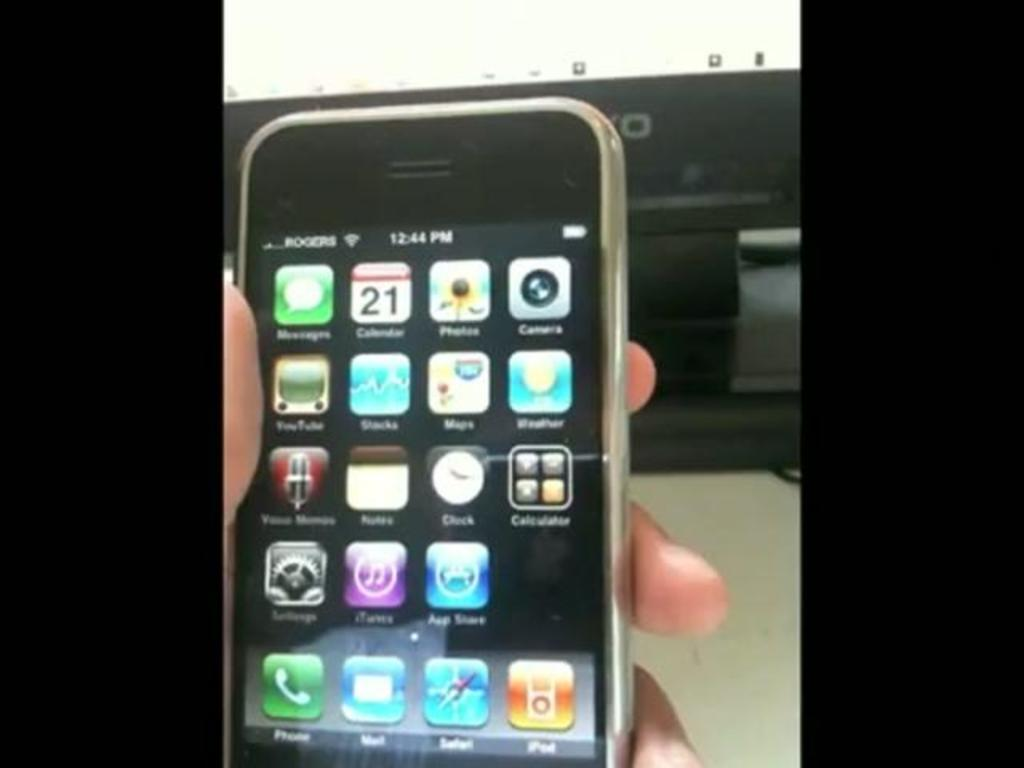<image>
Write a terse but informative summary of the picture. A person holding a mobile Apple device at 12:44 PM. 